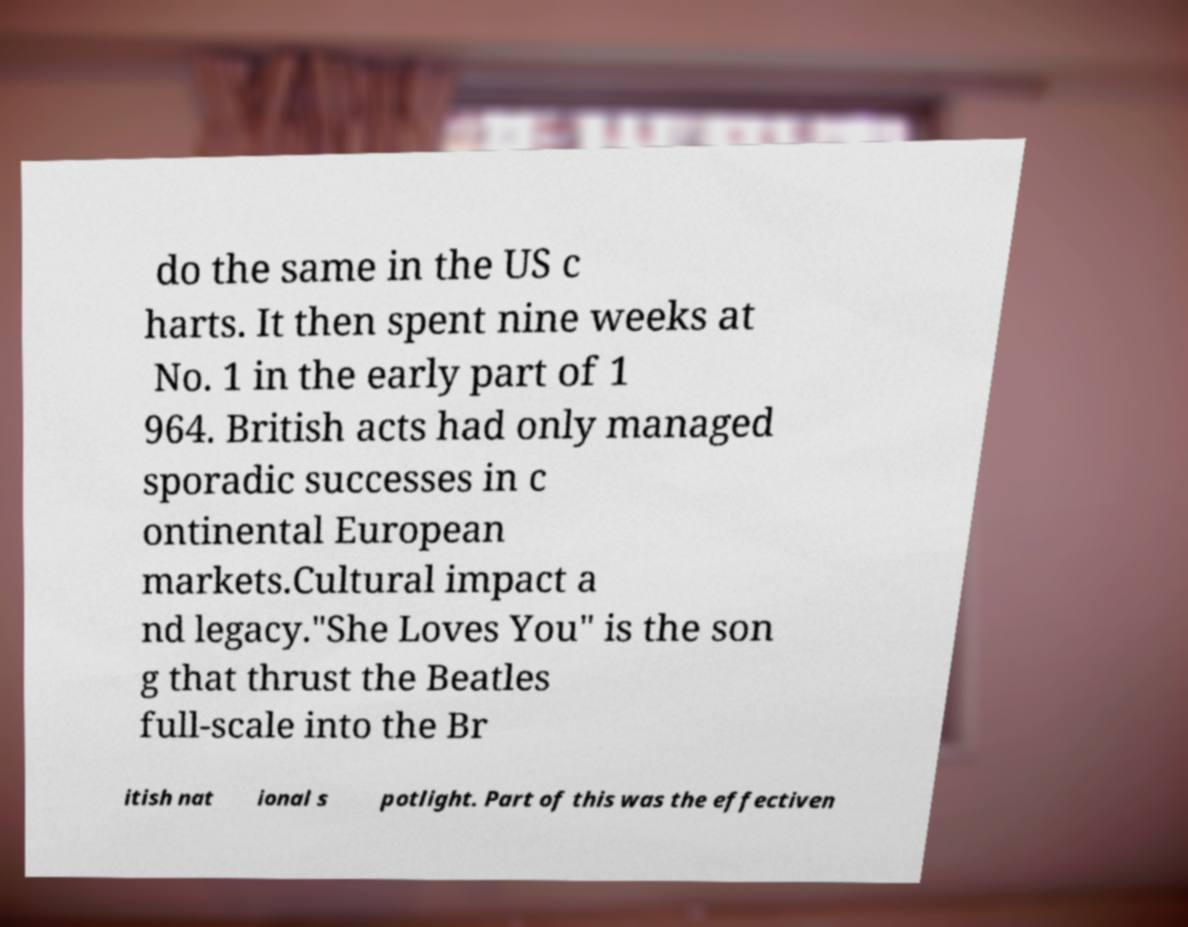Please identify and transcribe the text found in this image. do the same in the US c harts. It then spent nine weeks at No. 1 in the early part of 1 964. British acts had only managed sporadic successes in c ontinental European markets.Cultural impact a nd legacy."She Loves You" is the son g that thrust the Beatles full-scale into the Br itish nat ional s potlight. Part of this was the effectiven 